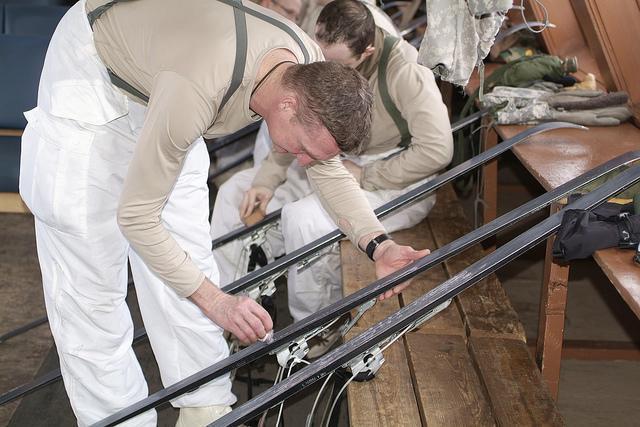How many ski can be seen?
Give a very brief answer. 2. How many people are there?
Give a very brief answer. 2. How many miniature horses are there in the field?
Give a very brief answer. 0. 